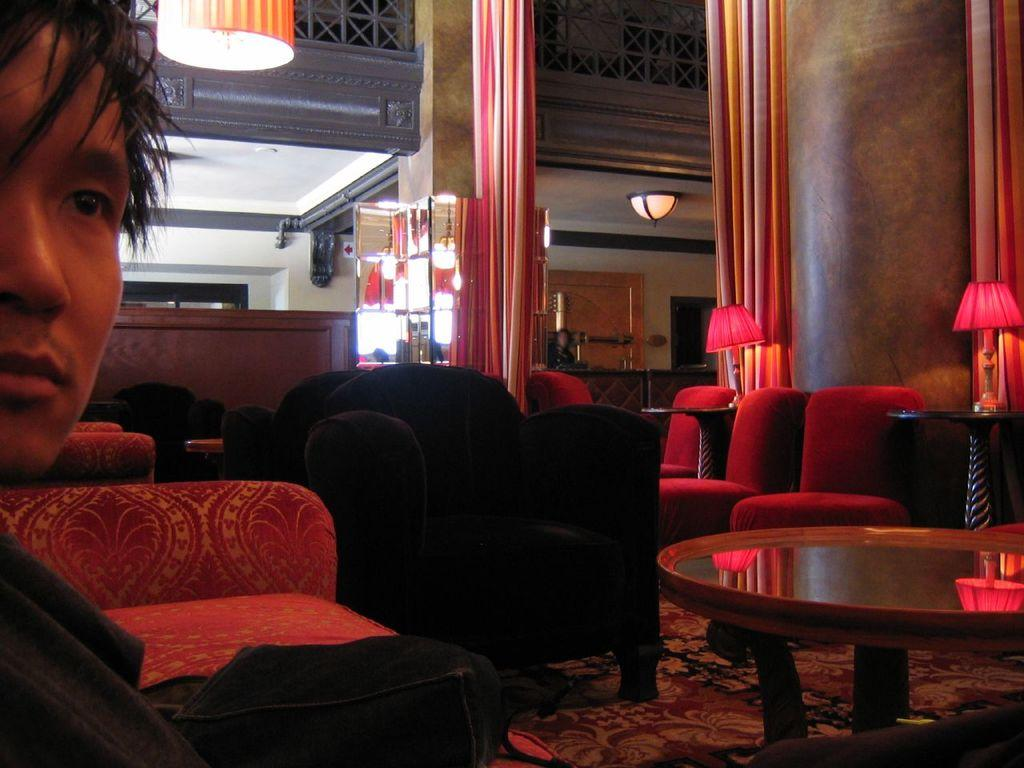Who is present in the image? There is a man in the image. What type of furniture can be seen in the image? There are chairs and tables in the image. What objects are on the tables? There are lamps on the tables. What can be seen in the background of the image? There are curtains, a wall, and a ceiling in the background of the image. What animal is telling a story in the image? There is no animal present in the image, nor is there any indication of a story being told. 